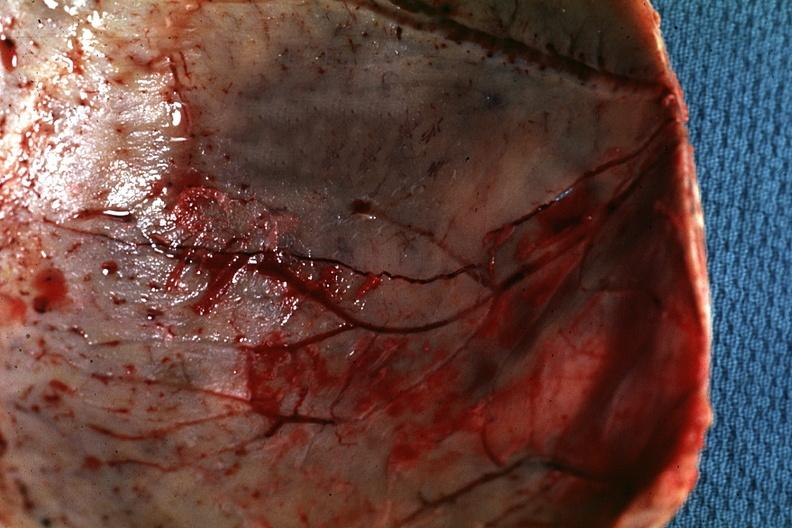does this image show fracture line well shown very thin skull eggshell type?
Answer the question using a single word or phrase. Yes 